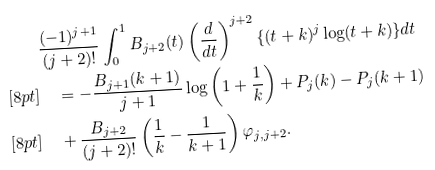<formula> <loc_0><loc_0><loc_500><loc_500>& \frac { ( - 1 ) ^ { j + 1 } } { ( j + 2 ) ! } \int _ { 0 } ^ { 1 } B _ { j + 2 } ( t ) \left ( \frac { d } { d t } \right ) ^ { j + 2 } \{ ( t + k ) ^ { j } \log ( t + k ) \} d t \\ [ 8 p t ] & \quad = - \frac { B _ { j + 1 } ( k + 1 ) } { j + 1 } \log \left ( 1 + \frac { 1 } { k } \right ) + P _ { j } ( k ) - P _ { j } ( k + 1 ) \\ [ 8 p t ] & \quad + \frac { B _ { j + 2 } } { ( j + 2 ) ! } \left ( \frac { 1 } { k } - \frac { 1 } { k + 1 } \right ) \varphi _ { j , j + 2 } .</formula> 